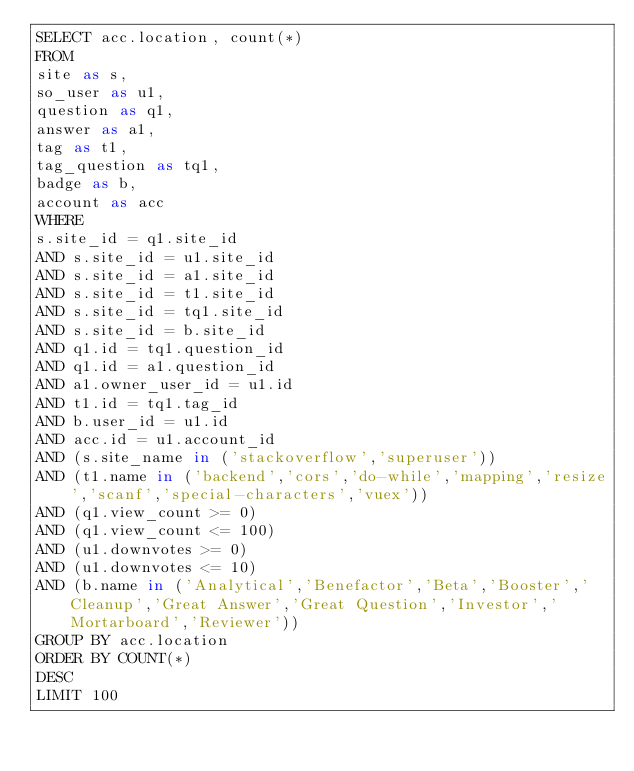Convert code to text. <code><loc_0><loc_0><loc_500><loc_500><_SQL_>SELECT acc.location, count(*)
FROM
site as s,
so_user as u1,
question as q1,
answer as a1,
tag as t1,
tag_question as tq1,
badge as b,
account as acc
WHERE
s.site_id = q1.site_id
AND s.site_id = u1.site_id
AND s.site_id = a1.site_id
AND s.site_id = t1.site_id
AND s.site_id = tq1.site_id
AND s.site_id = b.site_id
AND q1.id = tq1.question_id
AND q1.id = a1.question_id
AND a1.owner_user_id = u1.id
AND t1.id = tq1.tag_id
AND b.user_id = u1.id
AND acc.id = u1.account_id
AND (s.site_name in ('stackoverflow','superuser'))
AND (t1.name in ('backend','cors','do-while','mapping','resize','scanf','special-characters','vuex'))
AND (q1.view_count >= 0)
AND (q1.view_count <= 100)
AND (u1.downvotes >= 0)
AND (u1.downvotes <= 10)
AND (b.name in ('Analytical','Benefactor','Beta','Booster','Cleanup','Great Answer','Great Question','Investor','Mortarboard','Reviewer'))
GROUP BY acc.location
ORDER BY COUNT(*)
DESC
LIMIT 100
</code> 